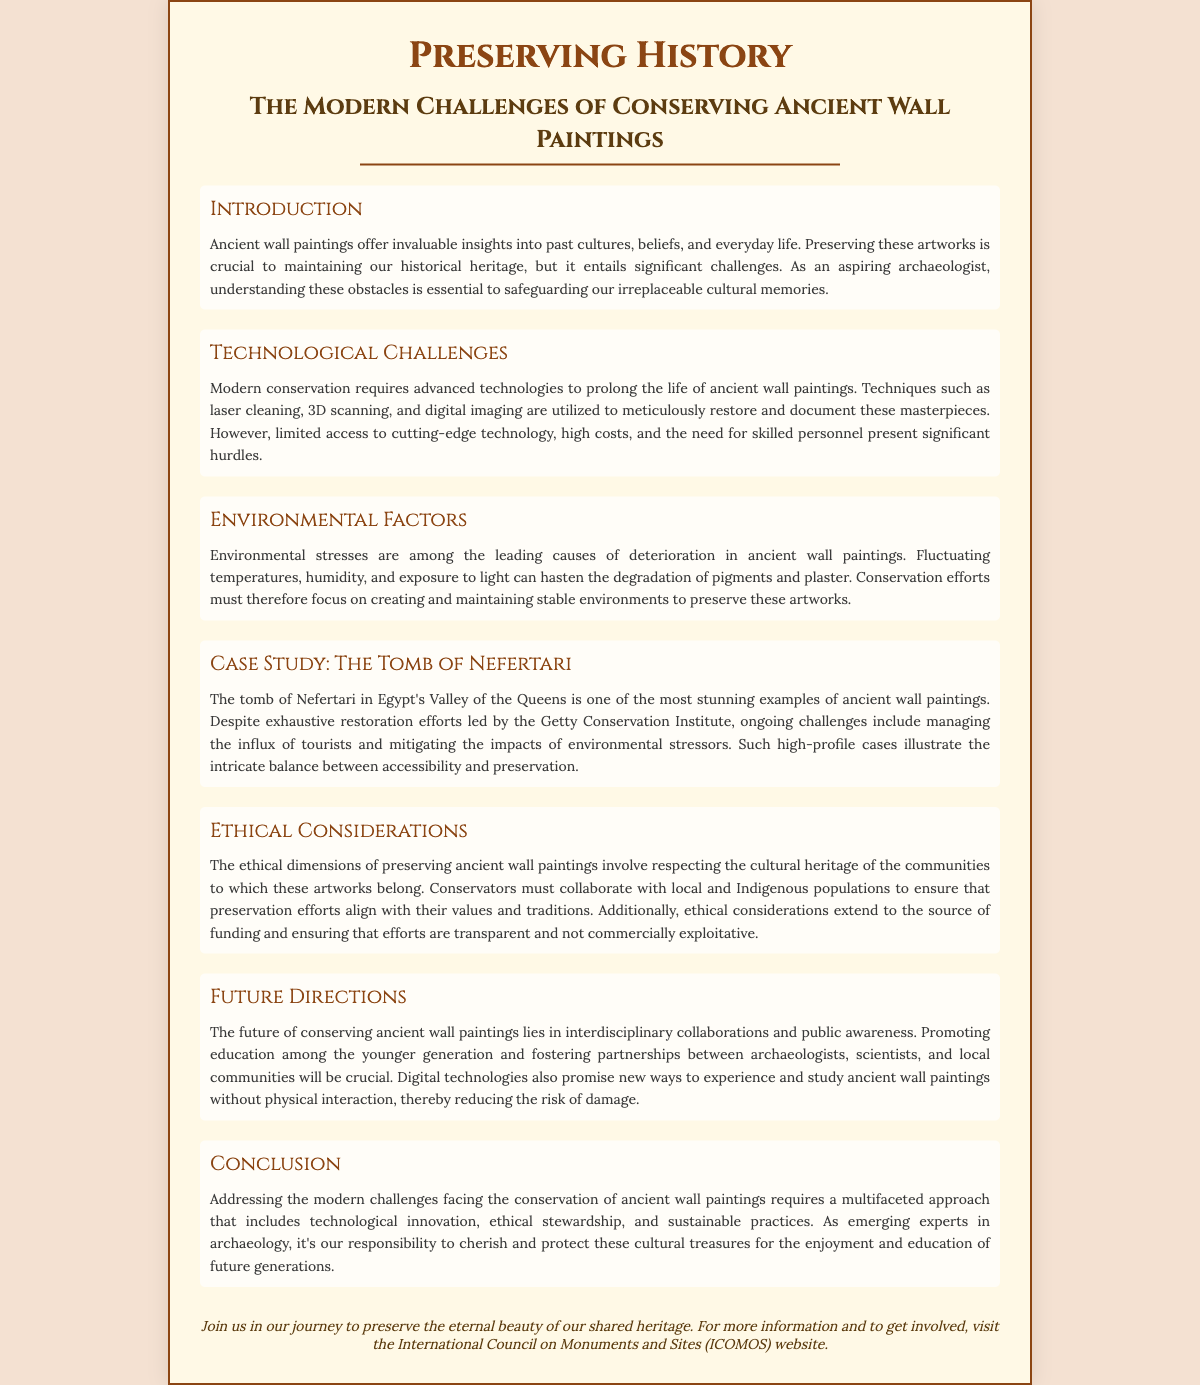What are ancient wall paintings important for? Ancient wall paintings provide insights into past cultures, beliefs, and everyday life.
Answer: Insights into past cultures What is one technological challenge mentioned? Advanced technologies such as laser cleaning and digital imaging are required, presenting significant hurdles like limited access.
Answer: Limited access to technology Which tomb is highlighted as a case study? The tomb of Nefertari in Egypt's Valley of the Queens is specifically mentioned.
Answer: Tomb of Nefertari What ethical aspect is essential in conservation? Collaborating with local and Indigenous populations is critical to align preservation efforts with their values.
Answer: Collaboration with local populations What is a recommended future direction for conservation? Promoting education among the younger generation is emphasized as a crucial future direction.
Answer: Promoting education What environmental factors impact ancient wall paintings? Fluctuating temperatures, humidity, and exposure to light are significant factors affecting the deterioration.
Answer: Fluctuating temperatures and humidity What does the conclusion emphasize? The conclusion highlights the need for technological innovation, ethical stewardship, and sustainable practices.
Answer: Technological innovation How many sections are in the document? There are a total of six main sections before the conclusion.
Answer: Six sections 